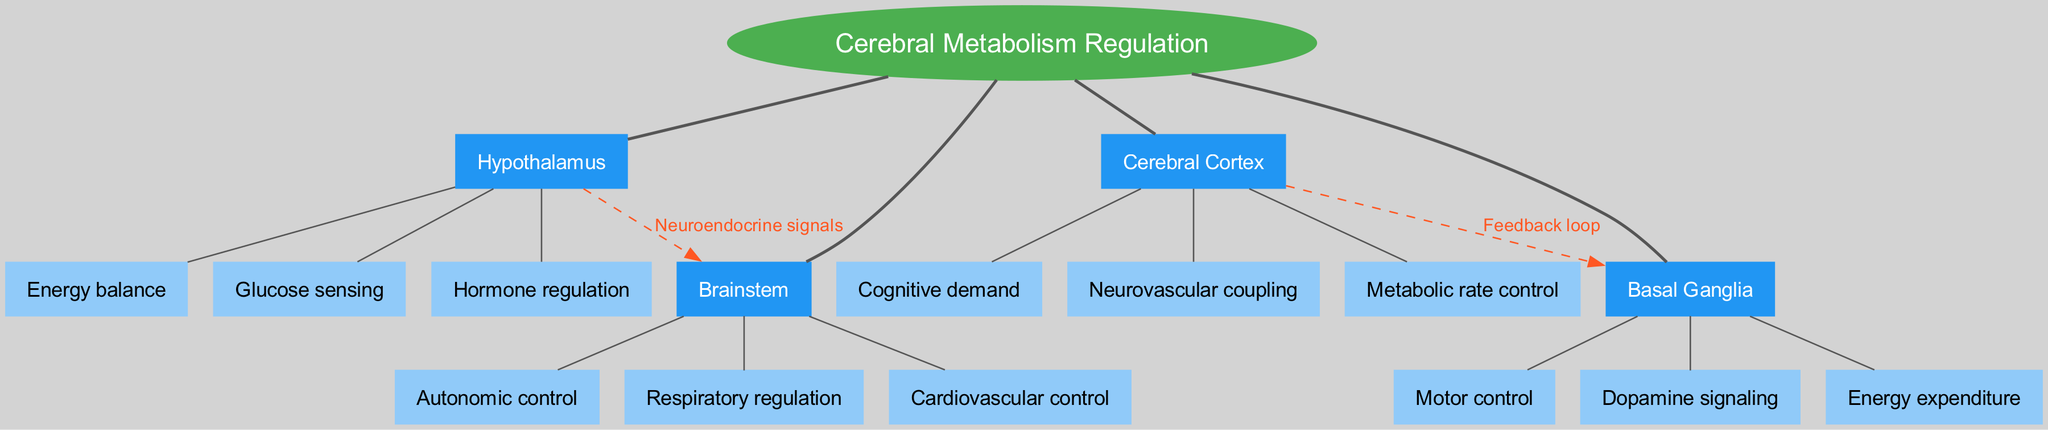What is the central topic of the diagram? The diagram's central topic is explicitly labeled in the center as "Cerebral Metabolism Regulation."
Answer: Cerebral Metabolism Regulation How many main branches are present in the diagram? The main branches are outlined directly under the central topic. In total, there are four main branches: Hypothalamus, Brainstem, Cerebral Cortex, and Basal Ganglia.
Answer: 4 What are the sub-branches of the Cerebral Cortex? The sub-branches are connected to the main branch 'Cerebral Cortex.' They include "Cognitive demand," "Neurovascular coupling," and "Metabolic rate control."
Answer: Cognitive demand, Neurovascular coupling, Metabolic rate control How does the Hypothalamus influence the Brainstem? According to the diagram, the influence is indicated by the connection labeled “Neuroendocrine signals” from the Hypothalamus to the Brainstem.
Answer: Neuroendocrine signals Which brain region is connected to the Basal Ganglia by a feedback loop? The diagram indicates that the Cerebral Cortex is connected to the Basal Ganglia with a labeled edge "Feedback loop."
Answer: Cerebral Cortex What are the primary functions represented by the sub-branches of the Brainstem? The sub-branches of the Brainstem are explicitly listed and include "Autonomic control," "Respiratory regulation," and "Cardiovascular control."
Answer: Autonomic control, Respiratory regulation, Cardiovascular control Which branch is associated with energy expenditure? The sub-branch "Energy expenditure" belongs to the Basal Ganglia as indicated in the diagram.
Answer: Basal Ganglia What type of relationship does the connection between Hypothalamus and Brainstem represent? The connection is indicated in the diagram as a dashed line, labeled "Neuroendocrine signals," which suggests a regulatory relationship.
Answer: Regulatory relationship How many sub-branches are listed under the Basal Ganglia? There are three distinct sub-branches under the Basal Ganglia: "Motor control," "Dopamine signaling," and "Energy expenditure."
Answer: 3 